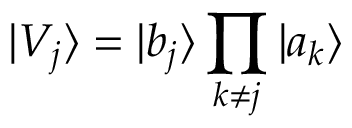Convert formula to latex. <formula><loc_0><loc_0><loc_500><loc_500>| V _ { j } \rangle = | b _ { j } \rangle \prod _ { k \neq j } | a _ { k } \rangle</formula> 